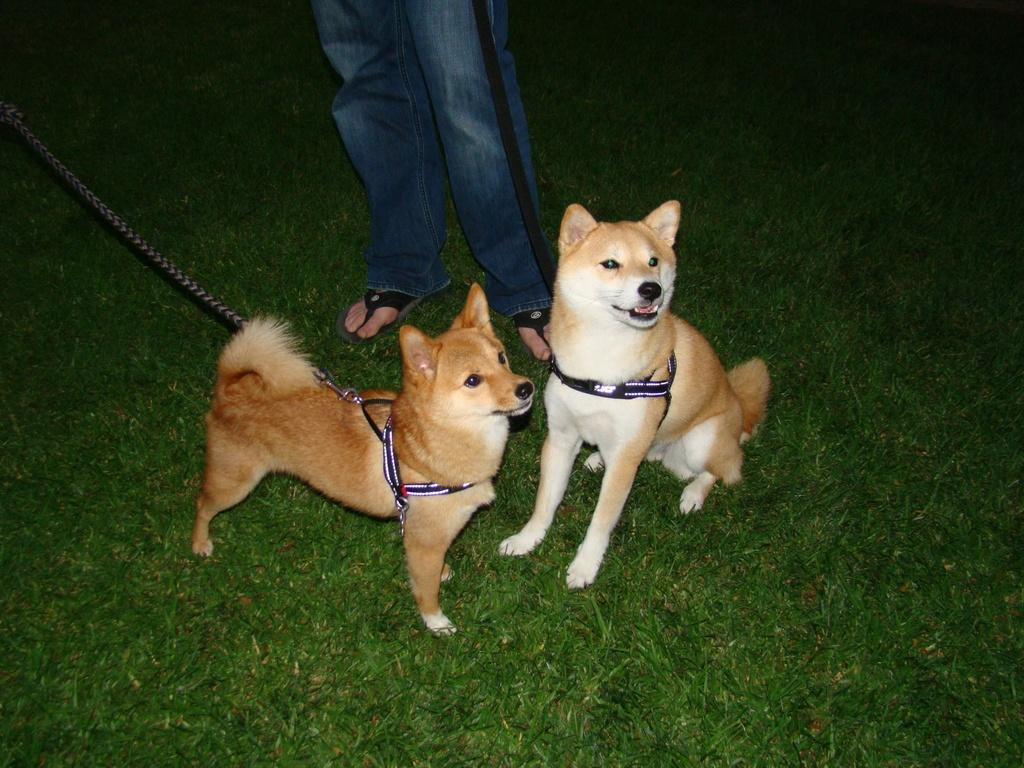How many dogs are present in the image? There are two dogs in the image. Can you describe the other living being in the image? There is a person in the image. What type of tramp can be seen interacting with the dogs in the image? There is no tramp present in the image; it only features two dogs and a person. Can you tell me how many donkeys are depicted in the image? There are no donkeys present in the image. 